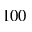<formula> <loc_0><loc_0><loc_500><loc_500>1 0 0</formula> 